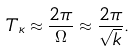<formula> <loc_0><loc_0><loc_500><loc_500>T _ { \kappa } \approx \frac { 2 \pi } { \Omega } \approx \frac { 2 \pi } { \sqrt { k } } .</formula> 